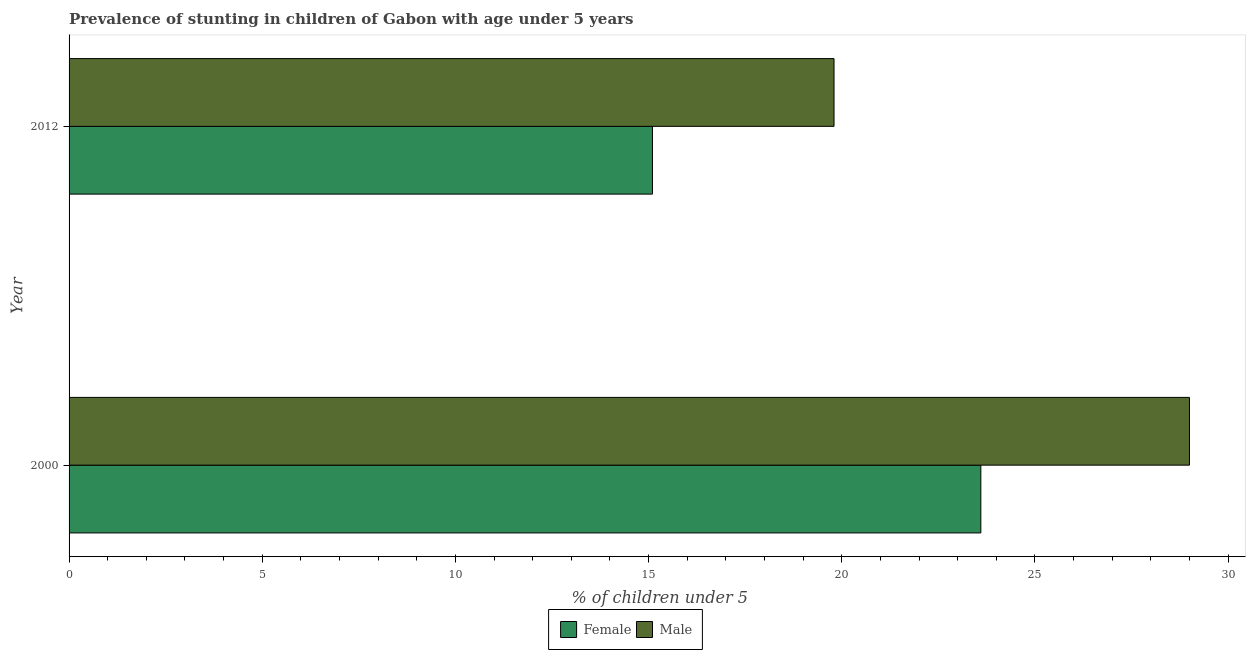How many different coloured bars are there?
Offer a terse response. 2. Are the number of bars on each tick of the Y-axis equal?
Provide a succinct answer. Yes. How many bars are there on the 1st tick from the bottom?
Your response must be concise. 2. What is the percentage of stunted female children in 2012?
Ensure brevity in your answer.  15.1. Across all years, what is the maximum percentage of stunted female children?
Keep it short and to the point. 23.6. Across all years, what is the minimum percentage of stunted female children?
Your answer should be compact. 15.1. What is the total percentage of stunted male children in the graph?
Your answer should be very brief. 48.8. What is the difference between the percentage of stunted female children in 2000 and that in 2012?
Offer a terse response. 8.5. What is the difference between the percentage of stunted female children in 2000 and the percentage of stunted male children in 2012?
Your answer should be very brief. 3.8. What is the average percentage of stunted male children per year?
Provide a short and direct response. 24.4. In the year 2012, what is the difference between the percentage of stunted male children and percentage of stunted female children?
Provide a short and direct response. 4.7. In how many years, is the percentage of stunted female children greater than 26 %?
Your answer should be very brief. 0. What is the ratio of the percentage of stunted male children in 2000 to that in 2012?
Your response must be concise. 1.47. Is the percentage of stunted female children in 2000 less than that in 2012?
Your response must be concise. No. Is the difference between the percentage of stunted male children in 2000 and 2012 greater than the difference between the percentage of stunted female children in 2000 and 2012?
Your response must be concise. Yes. What does the 1st bar from the top in 2012 represents?
Ensure brevity in your answer.  Male. How many bars are there?
Give a very brief answer. 4. How many years are there in the graph?
Offer a terse response. 2. What is the difference between two consecutive major ticks on the X-axis?
Ensure brevity in your answer.  5. Are the values on the major ticks of X-axis written in scientific E-notation?
Ensure brevity in your answer.  No. Does the graph contain any zero values?
Give a very brief answer. No. Does the graph contain grids?
Your answer should be very brief. No. How many legend labels are there?
Ensure brevity in your answer.  2. How are the legend labels stacked?
Provide a short and direct response. Horizontal. What is the title of the graph?
Ensure brevity in your answer.  Prevalence of stunting in children of Gabon with age under 5 years. What is the label or title of the X-axis?
Your answer should be very brief.  % of children under 5. What is the  % of children under 5 in Female in 2000?
Give a very brief answer. 23.6. What is the  % of children under 5 of Female in 2012?
Keep it short and to the point. 15.1. What is the  % of children under 5 in Male in 2012?
Provide a short and direct response. 19.8. Across all years, what is the maximum  % of children under 5 in Female?
Your answer should be compact. 23.6. Across all years, what is the minimum  % of children under 5 in Female?
Provide a succinct answer. 15.1. Across all years, what is the minimum  % of children under 5 of Male?
Provide a short and direct response. 19.8. What is the total  % of children under 5 in Female in the graph?
Provide a short and direct response. 38.7. What is the total  % of children under 5 in Male in the graph?
Provide a succinct answer. 48.8. What is the difference between the  % of children under 5 of Female in 2000 and the  % of children under 5 of Male in 2012?
Provide a short and direct response. 3.8. What is the average  % of children under 5 of Female per year?
Your answer should be very brief. 19.35. What is the average  % of children under 5 of Male per year?
Make the answer very short. 24.4. In the year 2000, what is the difference between the  % of children under 5 of Female and  % of children under 5 of Male?
Your answer should be compact. -5.4. What is the ratio of the  % of children under 5 of Female in 2000 to that in 2012?
Provide a succinct answer. 1.56. What is the ratio of the  % of children under 5 of Male in 2000 to that in 2012?
Keep it short and to the point. 1.46. What is the difference between the highest and the lowest  % of children under 5 in Male?
Provide a short and direct response. 9.2. 